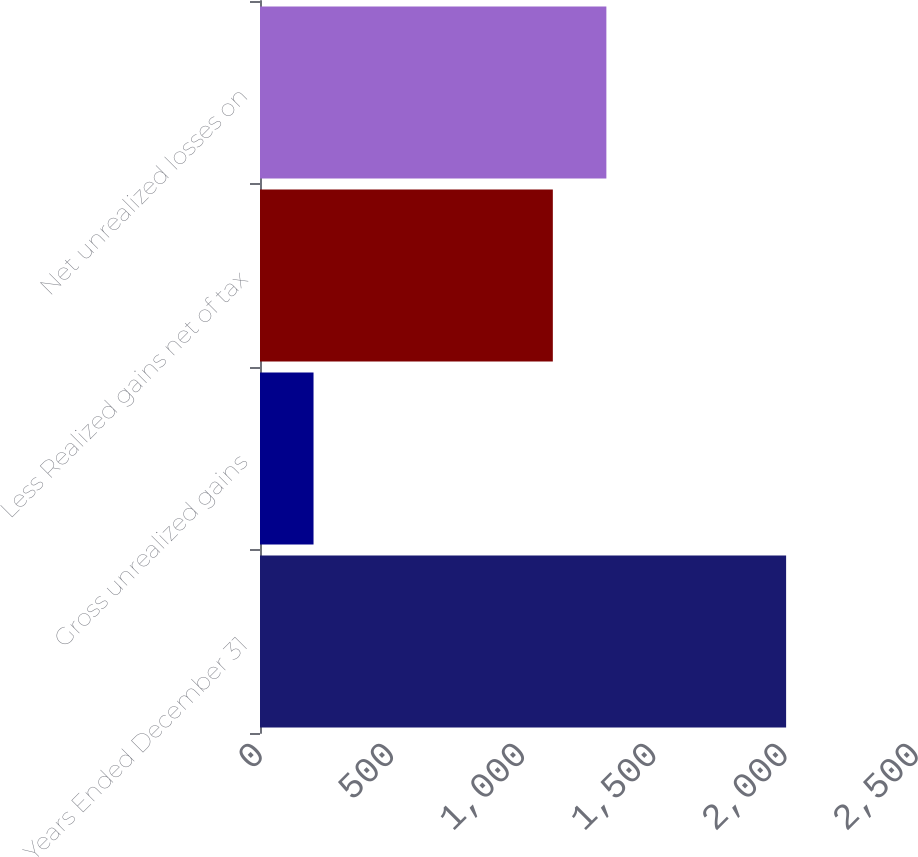Convert chart. <chart><loc_0><loc_0><loc_500><loc_500><bar_chart><fcel>Years Ended December 31<fcel>Gross unrealized gains<fcel>Less Realized gains net of tax<fcel>Net unrealized losses on<nl><fcel>2005<fcel>204<fcel>1116<fcel>1320<nl></chart> 